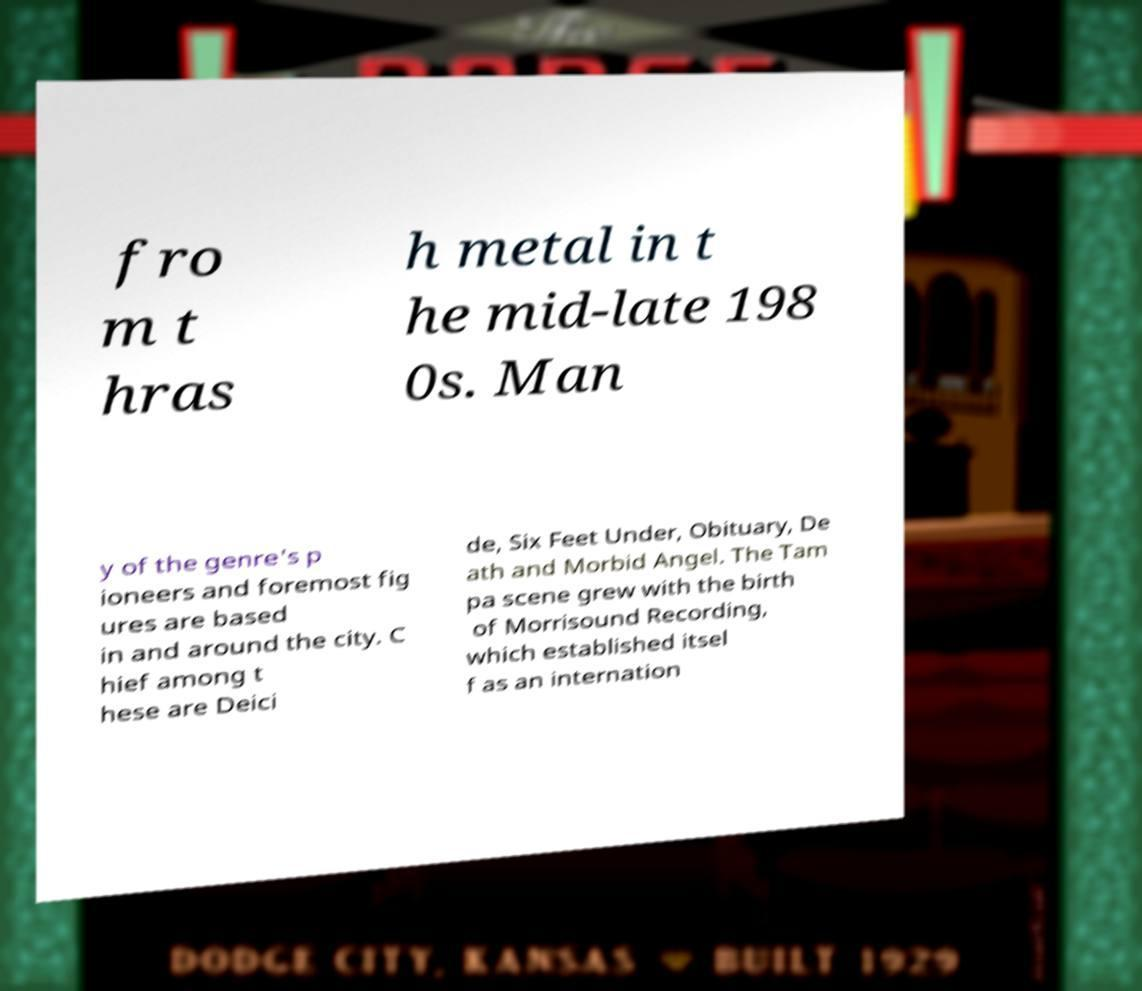There's text embedded in this image that I need extracted. Can you transcribe it verbatim? fro m t hras h metal in t he mid-late 198 0s. Man y of the genre's p ioneers and foremost fig ures are based in and around the city. C hief among t hese are Deici de, Six Feet Under, Obituary, De ath and Morbid Angel. The Tam pa scene grew with the birth of Morrisound Recording, which established itsel f as an internation 